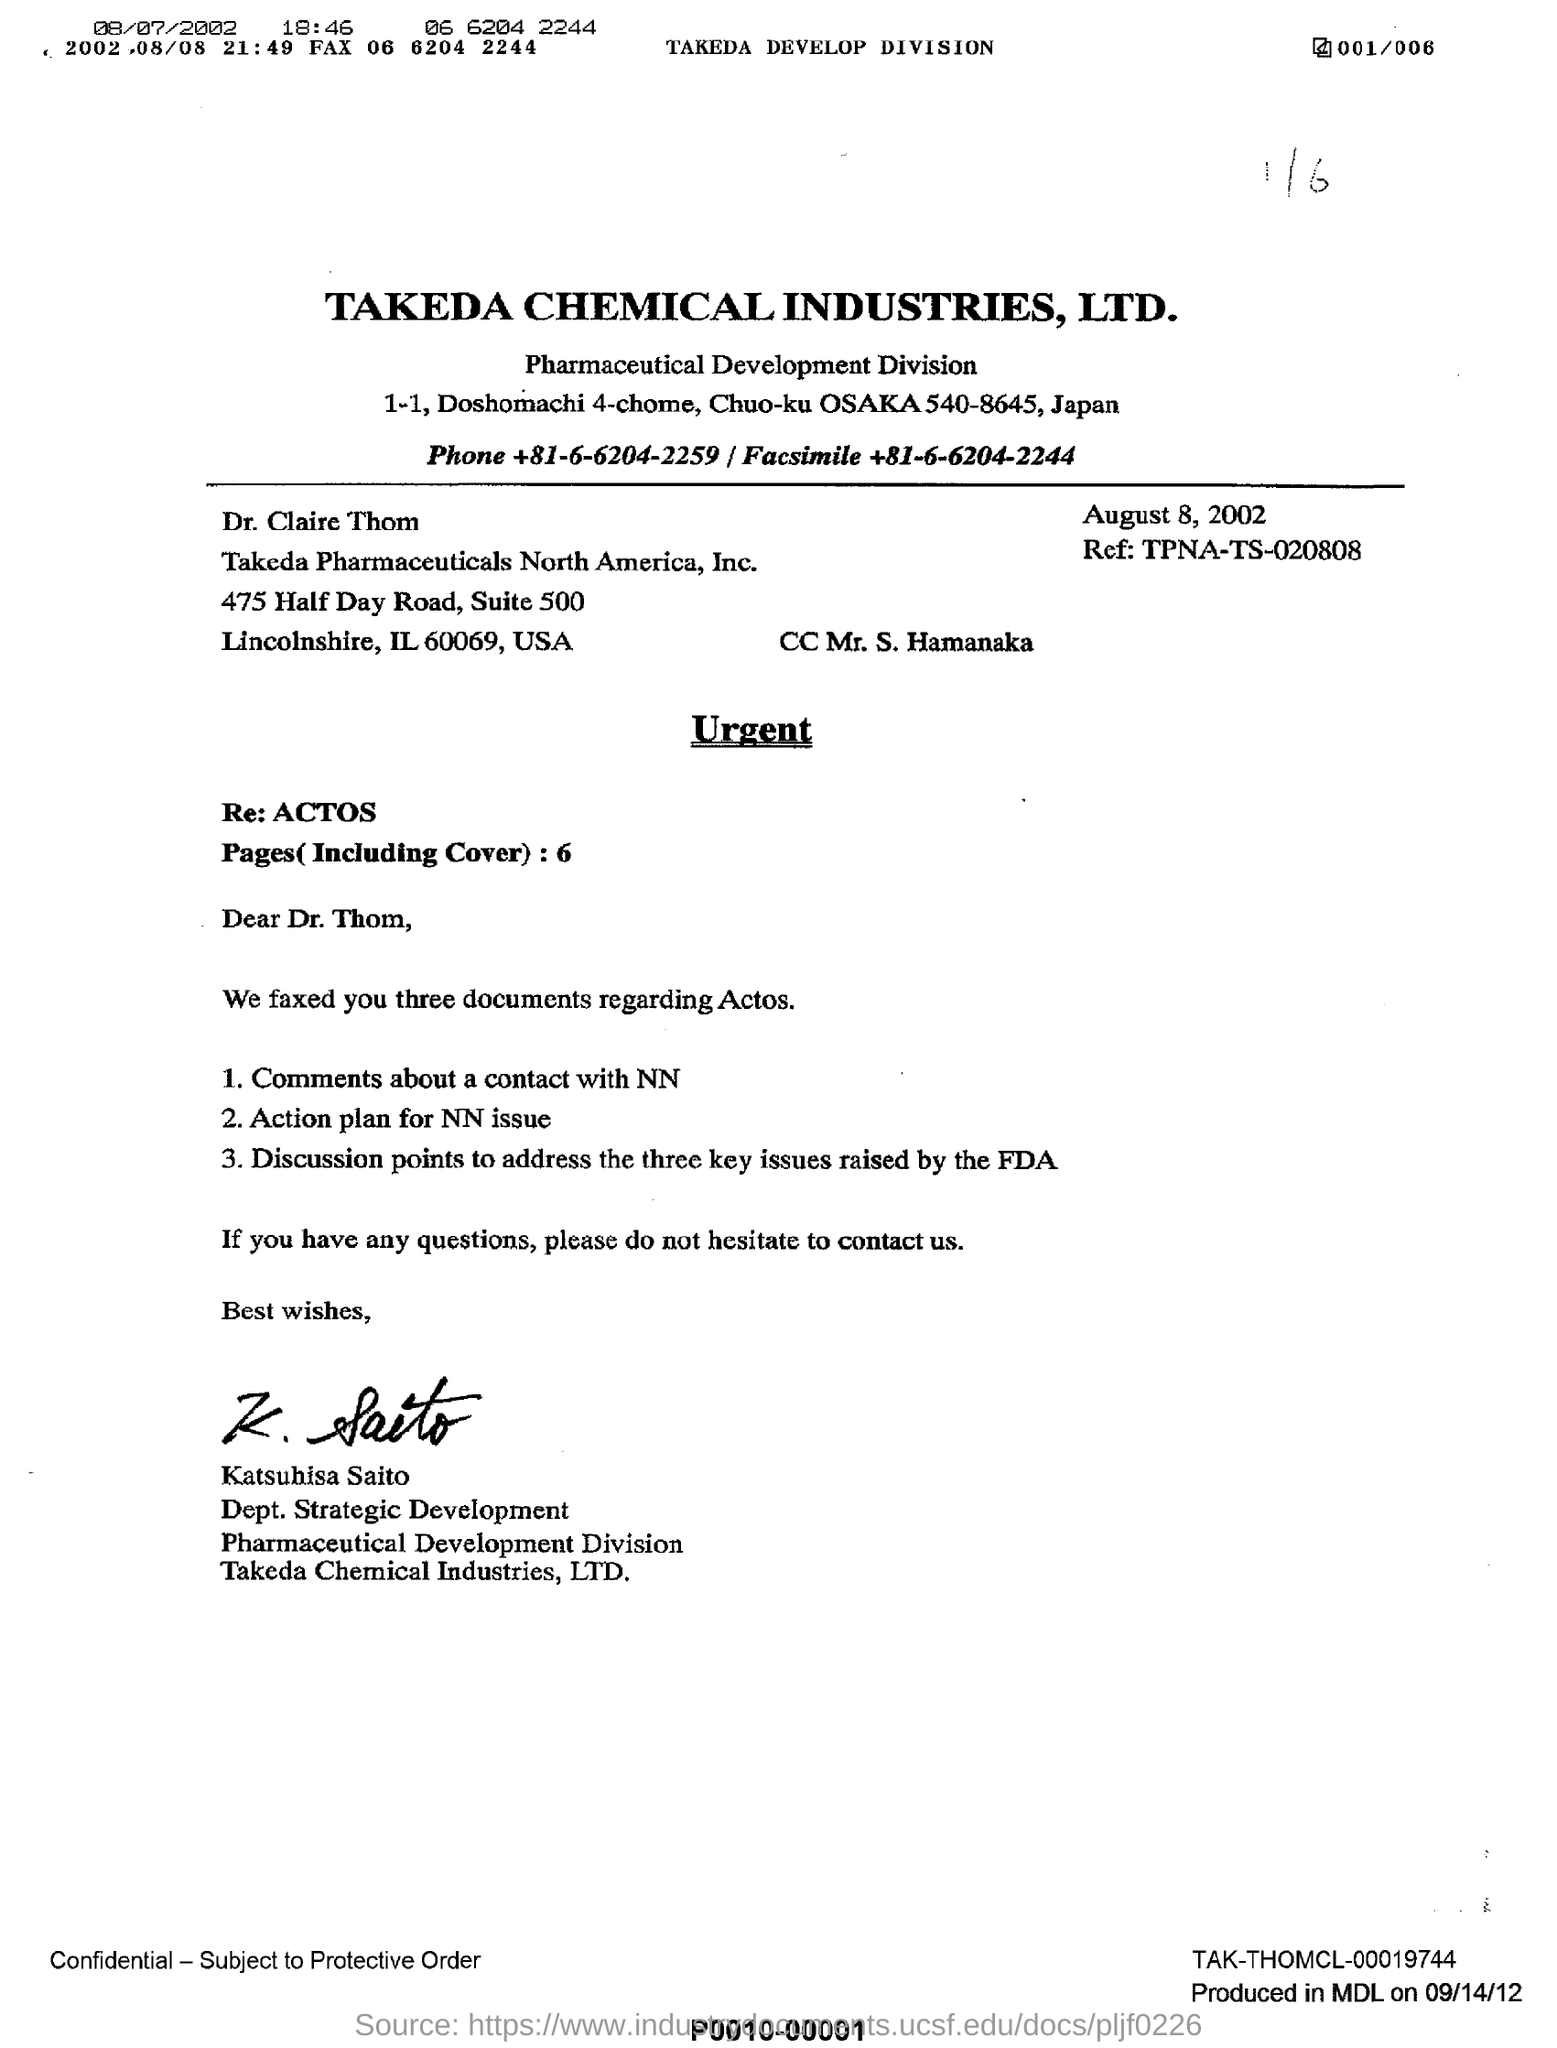What is the date mentioned in  the letter
Give a very brief answer. August 8 , 2002. What is the name of the industry given here?
Make the answer very short. Takeda chemical industries, LTD . To whom this letter is written ?
Keep it short and to the point. Dr. Thom. What is the name mentioned in cc
Offer a terse response. Mr . S . Hamanaka. Who sent this letter?
Your response must be concise. Katsuhisa Saito. What is ref: code  mentioned ?
Give a very brief answer. TPNA-TS-020808. 